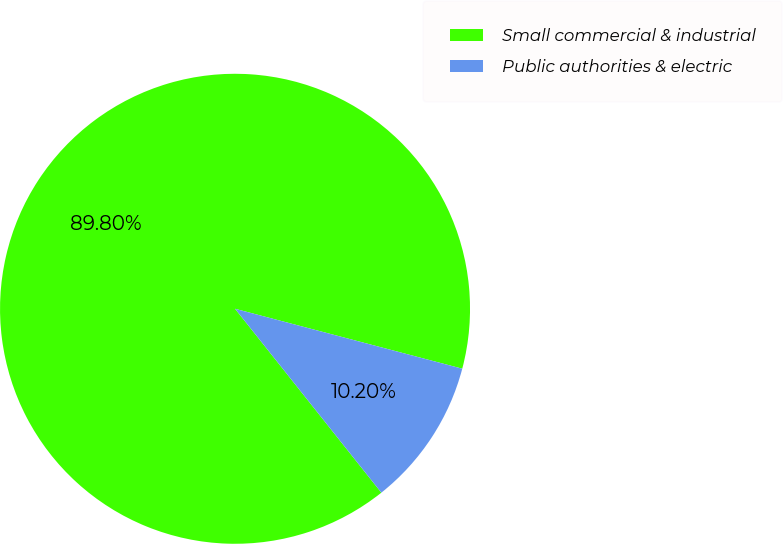Convert chart. <chart><loc_0><loc_0><loc_500><loc_500><pie_chart><fcel>Small commercial & industrial<fcel>Public authorities & electric<nl><fcel>89.8%<fcel>10.2%<nl></chart> 